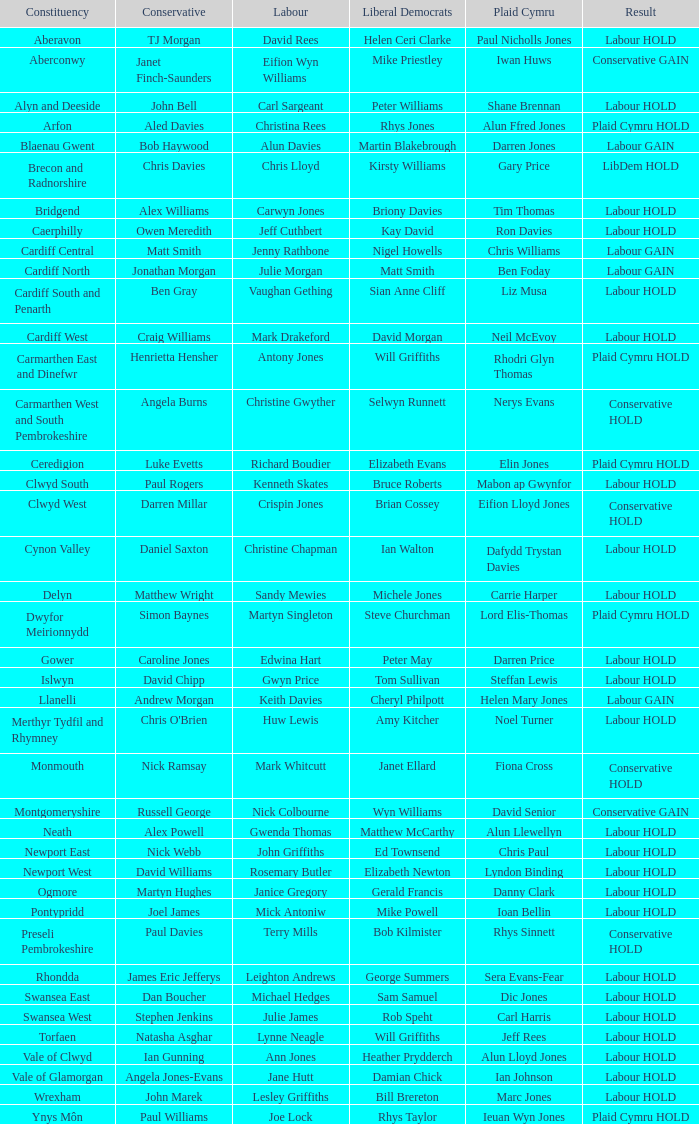In which constituency did the labour party maintain their position and liberal democrat elizabeth newton emerge victorious? Newport West. 